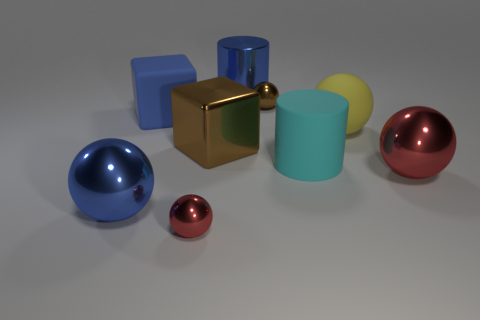Is the number of small metallic things less than the number of large blue metallic cylinders?
Make the answer very short. No. There is a big thing that is both behind the cyan rubber object and in front of the yellow ball; what is its shape?
Your answer should be very brief. Cube. What number of tiny gray objects are there?
Give a very brief answer. 0. There is a small ball that is to the right of the small metallic thing on the left side of the blue cylinder that is behind the small brown metal sphere; what is it made of?
Provide a succinct answer. Metal. How many large blue things are in front of the rubber object to the left of the tiny red thing?
Give a very brief answer. 1. There is another big thing that is the same shape as the cyan rubber object; what is its color?
Keep it short and to the point. Blue. Does the small brown ball have the same material as the big red sphere?
Keep it short and to the point. Yes. How many cubes are big gray things or big red shiny things?
Give a very brief answer. 0. What is the size of the brown thing that is on the right side of the blue thing behind the small metallic object behind the tiny red ball?
Keep it short and to the point. Small. What is the size of the brown thing that is the same shape as the blue rubber thing?
Ensure brevity in your answer.  Large. 